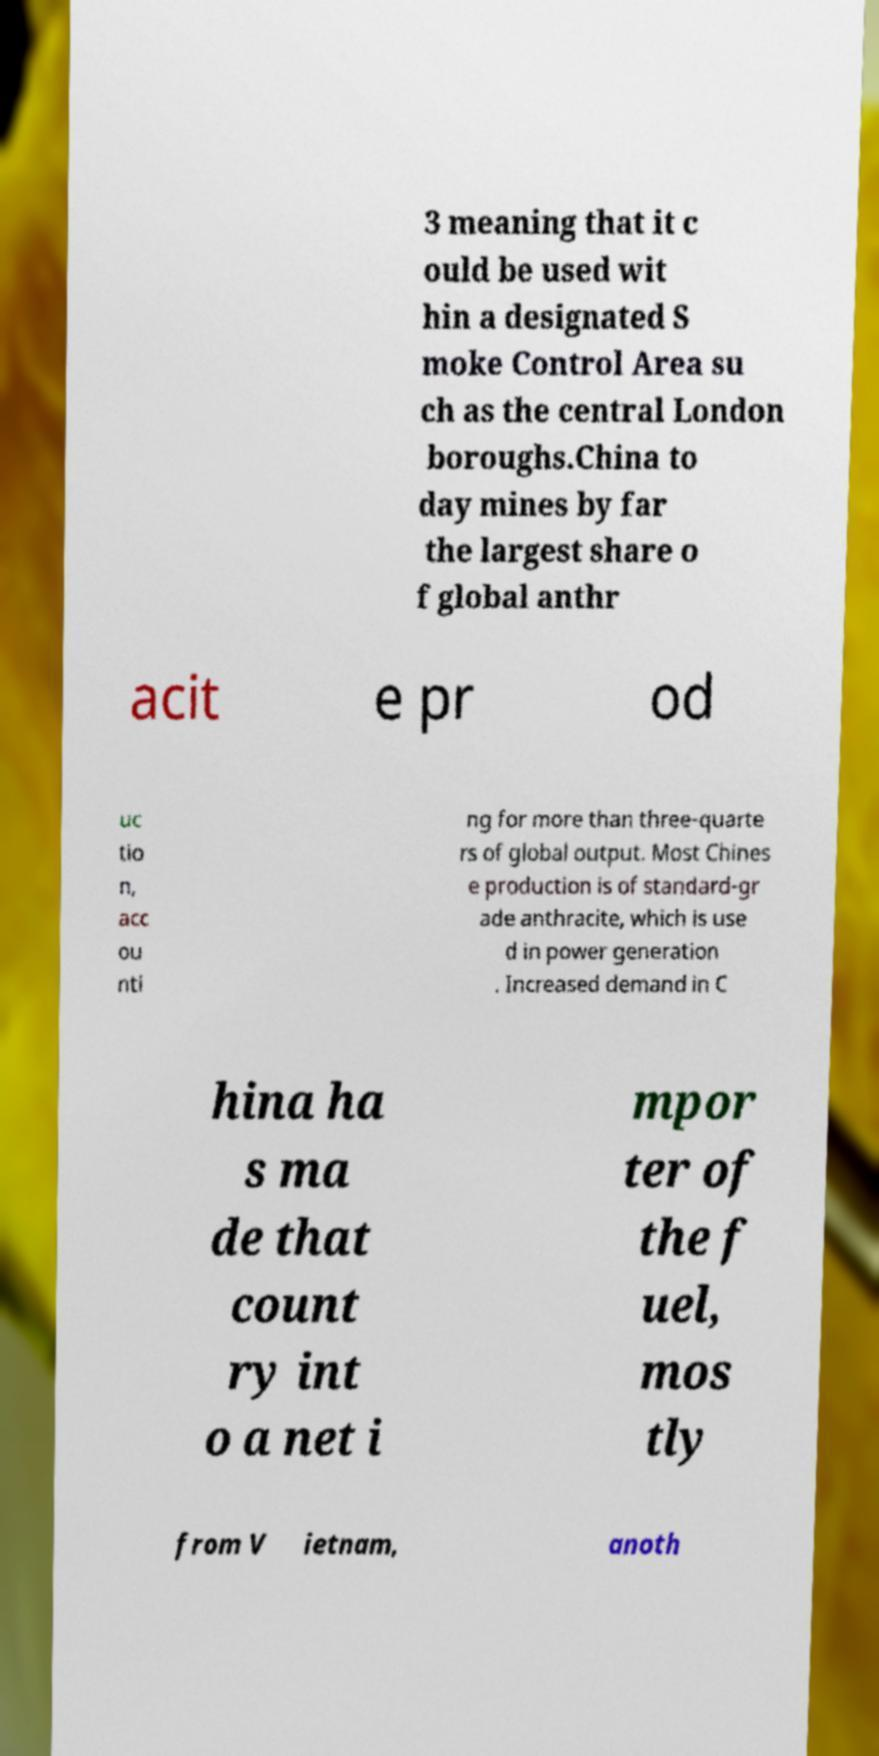For documentation purposes, I need the text within this image transcribed. Could you provide that? 3 meaning that it c ould be used wit hin a designated S moke Control Area su ch as the central London boroughs.China to day mines by far the largest share o f global anthr acit e pr od uc tio n, acc ou nti ng for more than three-quarte rs of global output. Most Chines e production is of standard-gr ade anthracite, which is use d in power generation . Increased demand in C hina ha s ma de that count ry int o a net i mpor ter of the f uel, mos tly from V ietnam, anoth 